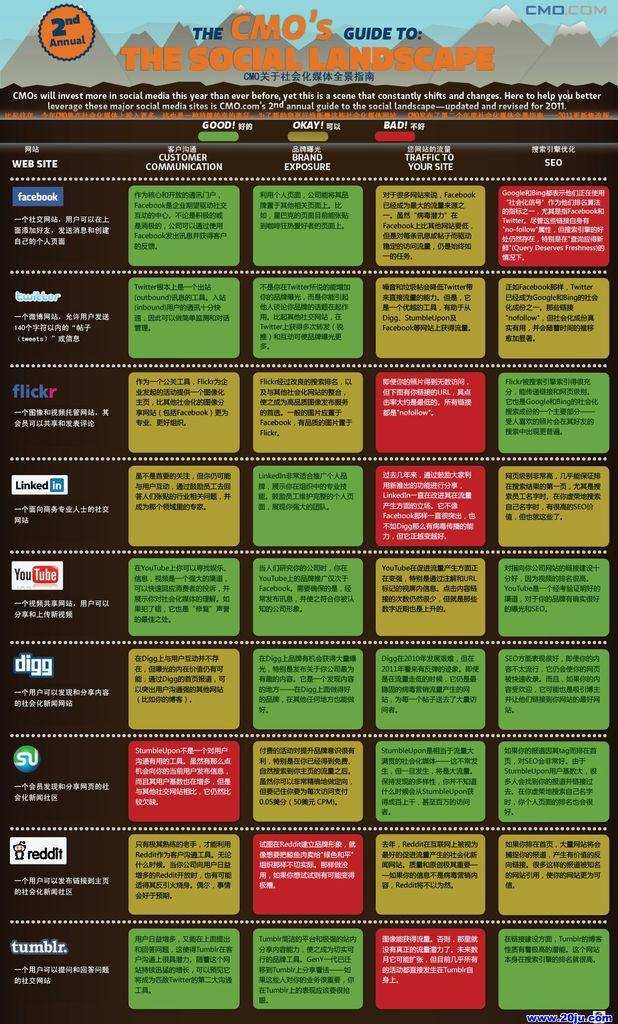<image>
Describe the image concisely. 2nd Annual The CMO's guide to the Social Landscape showing a table in green, red, and yellow grids. 